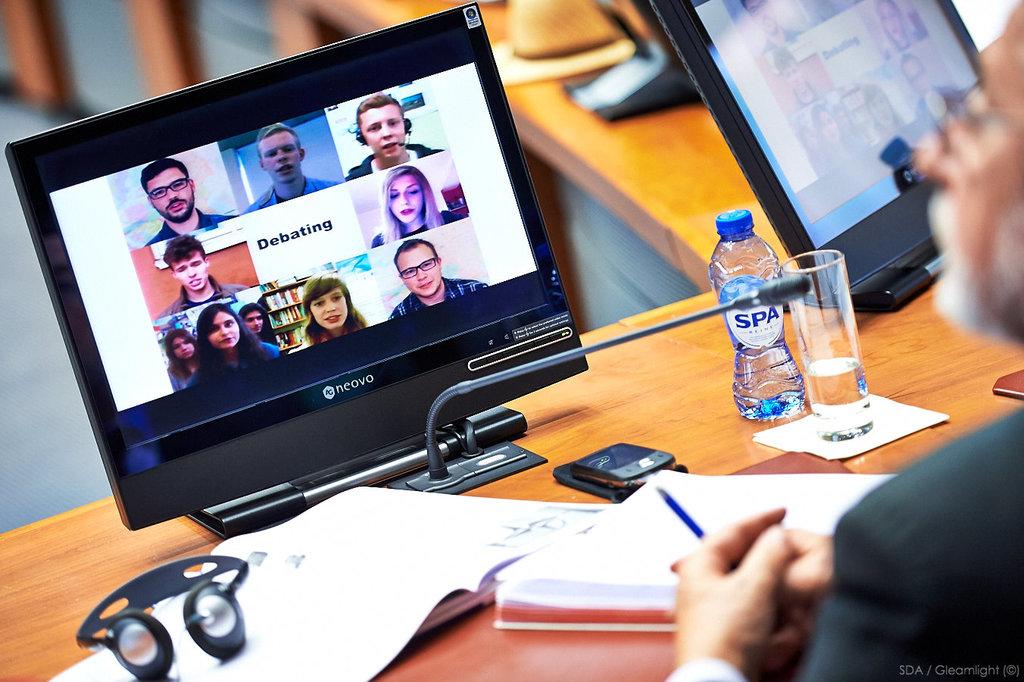What brand of water is in the bottle?
Your response must be concise. Spa. 